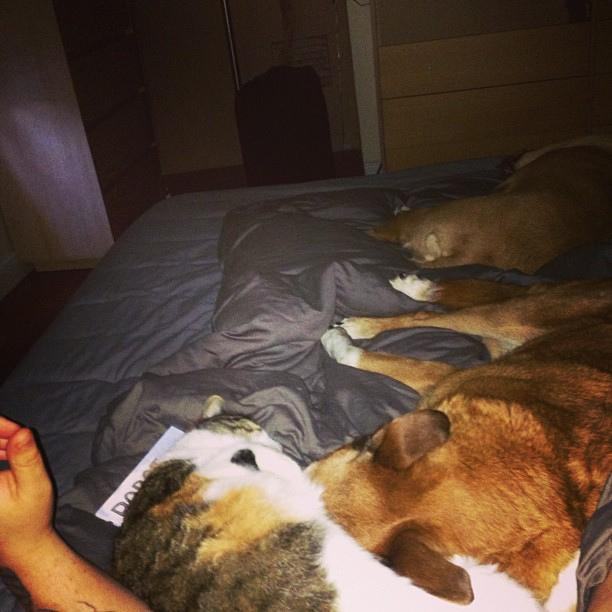The cat is cozying up to what animal? dog 